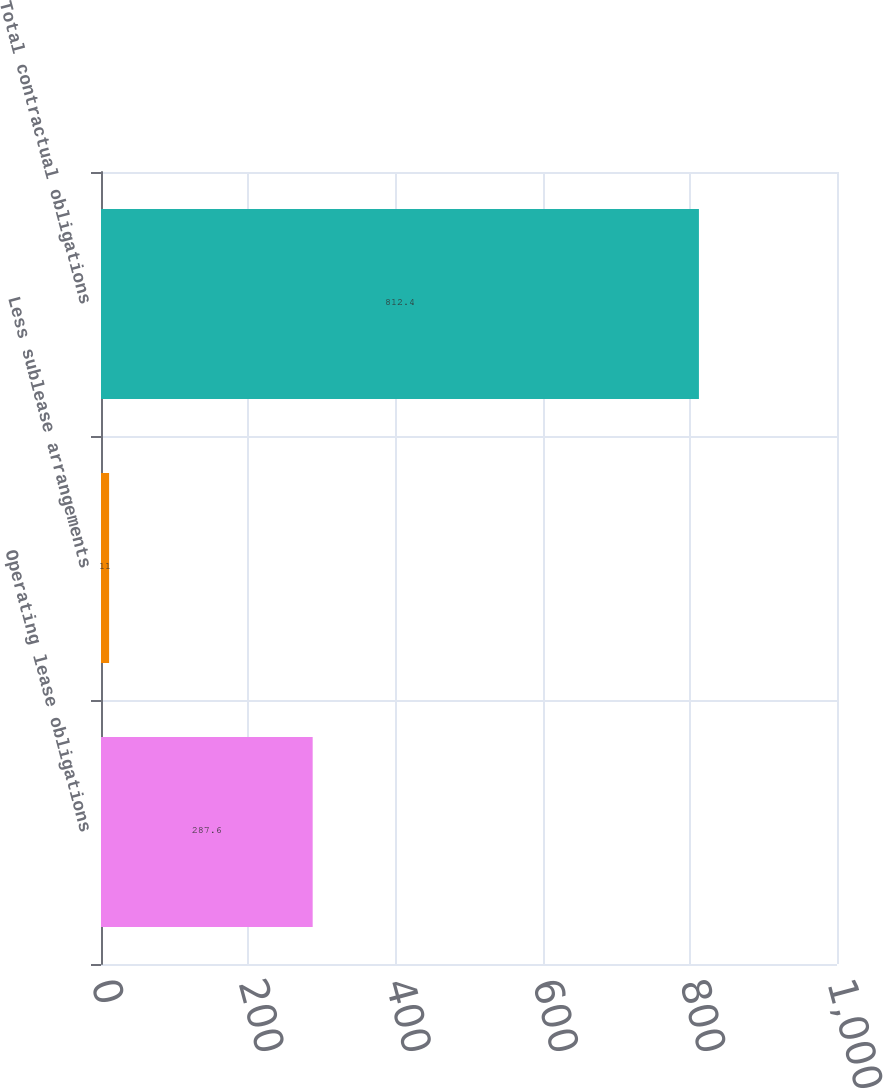Convert chart to OTSL. <chart><loc_0><loc_0><loc_500><loc_500><bar_chart><fcel>Operating lease obligations<fcel>Less sublease arrangements<fcel>Total contractual obligations<nl><fcel>287.6<fcel>11<fcel>812.4<nl></chart> 